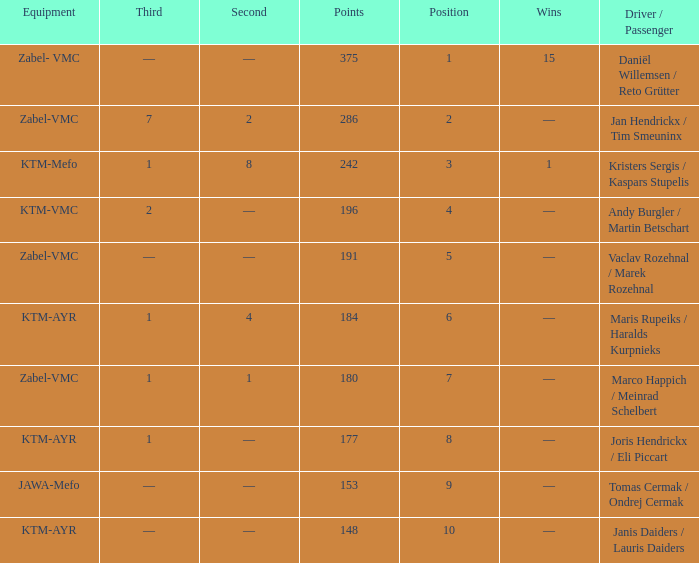Who was the driver/passengar when the position was smaller than 8, the third was 1, and there was 1 win? Kristers Sergis / Kaspars Stupelis. 